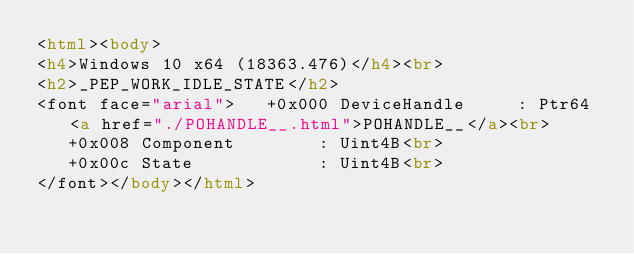Convert code to text. <code><loc_0><loc_0><loc_500><loc_500><_HTML_><html><body>
<h4>Windows 10 x64 (18363.476)</h4><br>
<h2>_PEP_WORK_IDLE_STATE</h2>
<font face="arial">   +0x000 DeviceHandle     : Ptr64 <a href="./POHANDLE__.html">POHANDLE__</a><br>
   +0x008 Component        : Uint4B<br>
   +0x00c State            : Uint4B<br>
</font></body></html></code> 